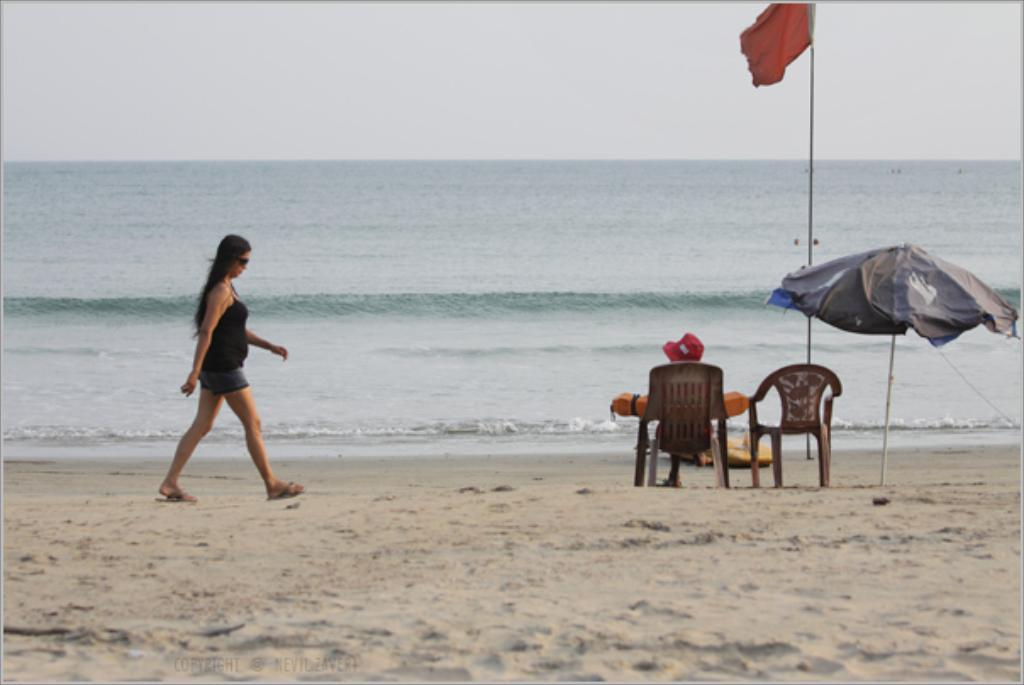Who is the main subject in the image? There is a woman in the image. What is the woman doing in the image? The woman is walking on the beach. Can you describe the other person in the image? There is a person sitting in a chair in the image. What is the person doing while sitting in the chair? The person is looking at the sea. How many chickens are present in the image? There are no chickens present in the image. 